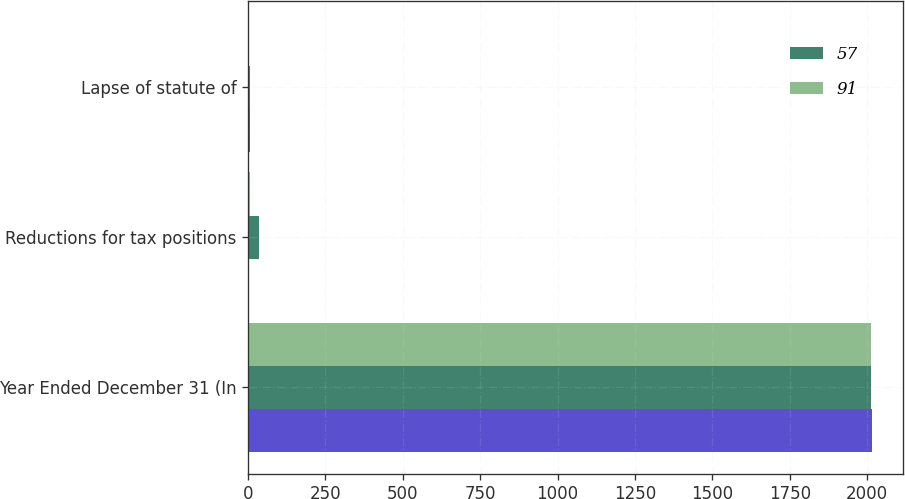Convert chart. <chart><loc_0><loc_0><loc_500><loc_500><stacked_bar_chart><ecel><fcel>Year Ended December 31 (In<fcel>Reductions for tax positions<fcel>Lapse of statute of<nl><fcel>nan<fcel>2015<fcel>3<fcel>7<nl><fcel>57<fcel>2014<fcel>35<fcel>5<nl><fcel>91<fcel>2013<fcel>7<fcel>2<nl></chart> 